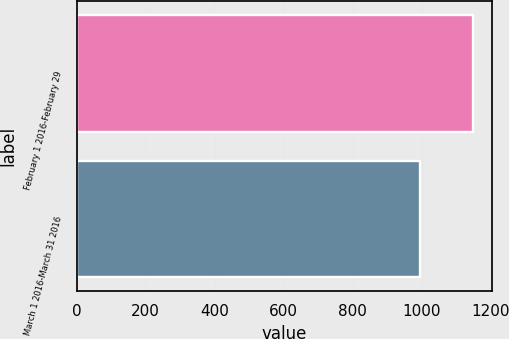Convert chart to OTSL. <chart><loc_0><loc_0><loc_500><loc_500><bar_chart><fcel>February 1 2016-February 29<fcel>March 1 2016-March 31 2016<nl><fcel>1148<fcel>996<nl></chart> 